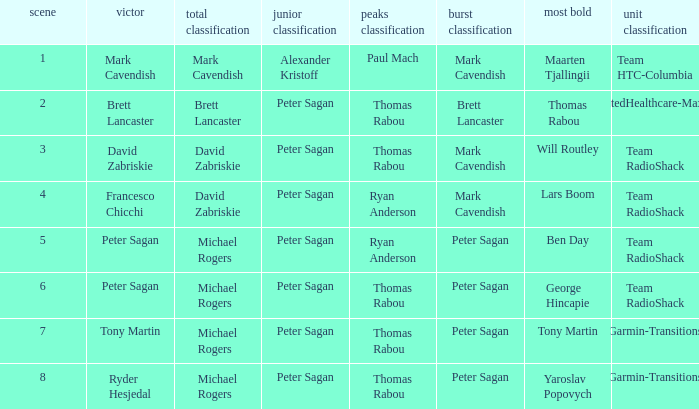When Peter Sagan won the youth classification and Thomas Rabou won the most corageous, who won the sprint classification? Brett Lancaster. 